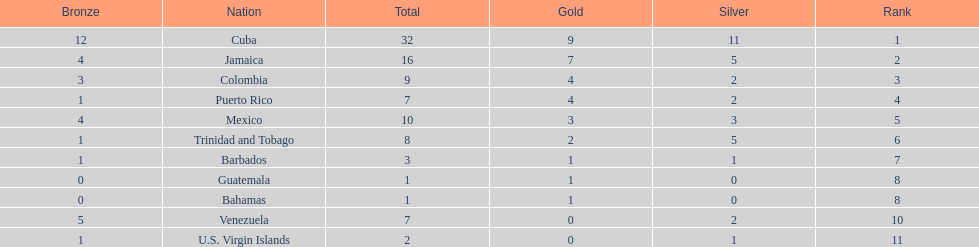Number of teams above 9 medals 3. 